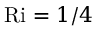<formula> <loc_0><loc_0><loc_500><loc_500>R i = 1 / 4</formula> 